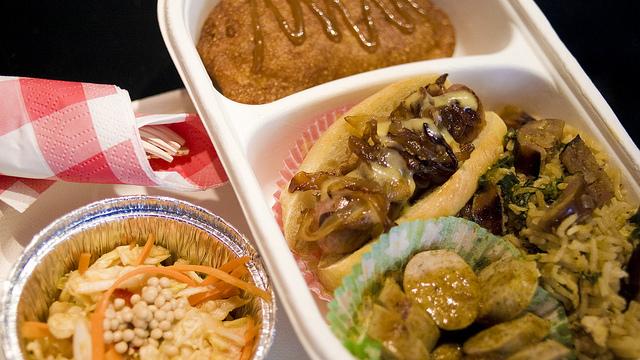Is this a balanced meal?
Quick response, please. No. What's wrapped up in the checkered napkin?
Keep it brief. Utensils. Is the white material biodegradable?
Concise answer only. No. 